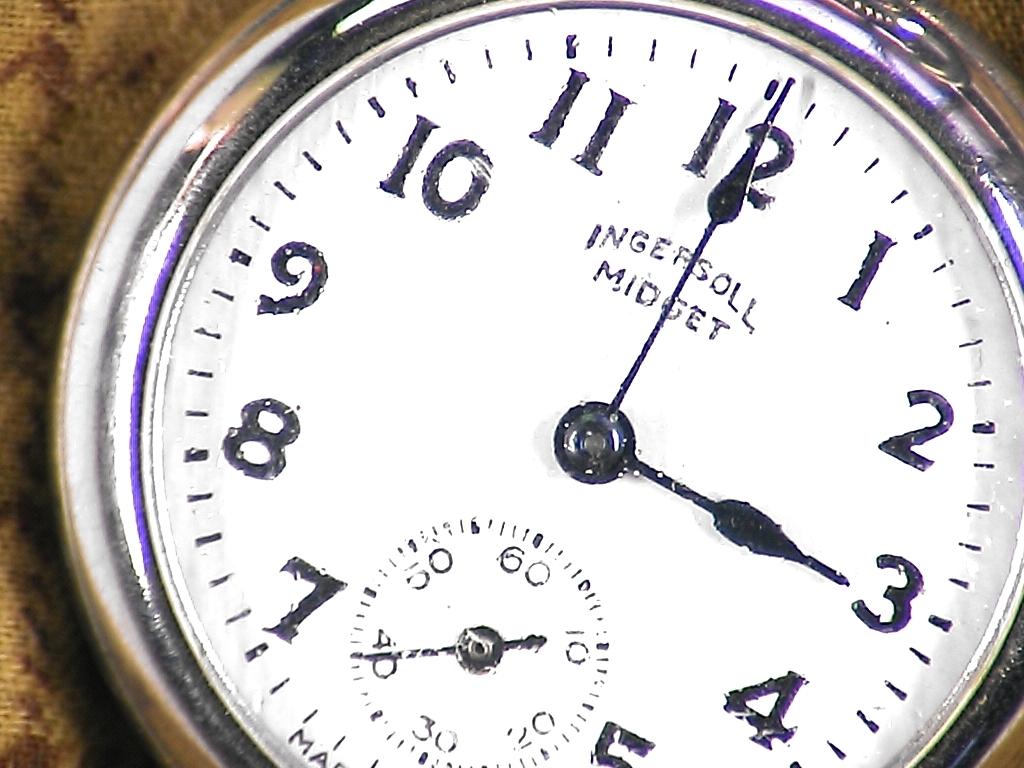What words are read under the number 12?
Provide a succinct answer. Ingersoll midget. 